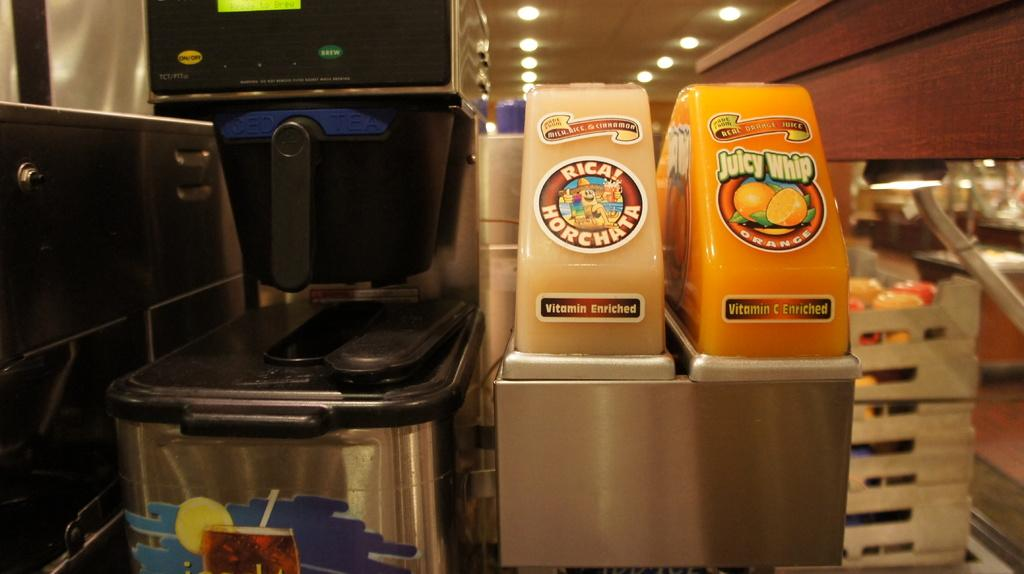<image>
Give a short and clear explanation of the subsequent image. Two beverage dispensers with one of them offering Juicy Whip 